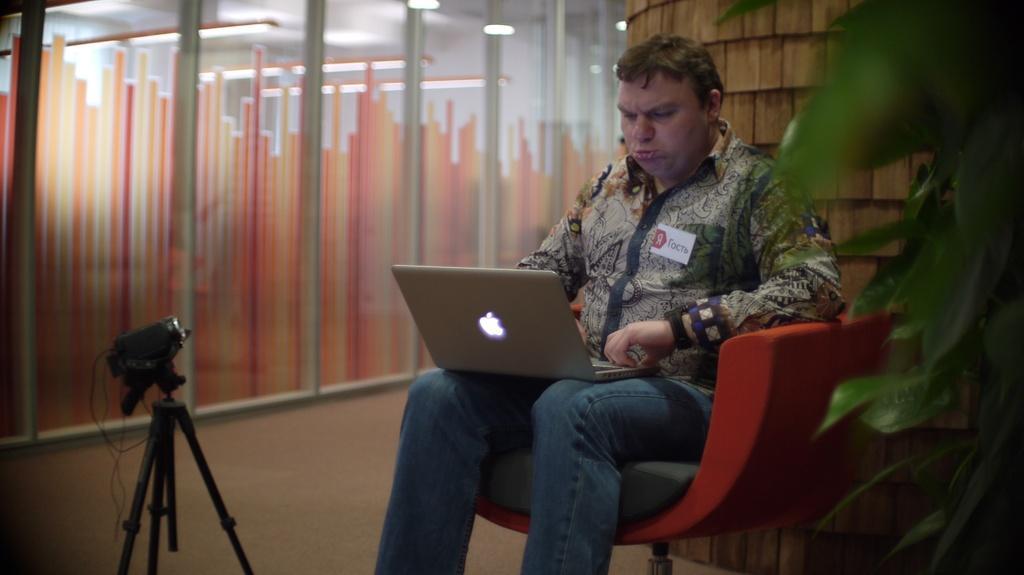Please provide a concise description of this image. A man is sitting on the chair and working in the laptop left side there is a glass wall. 